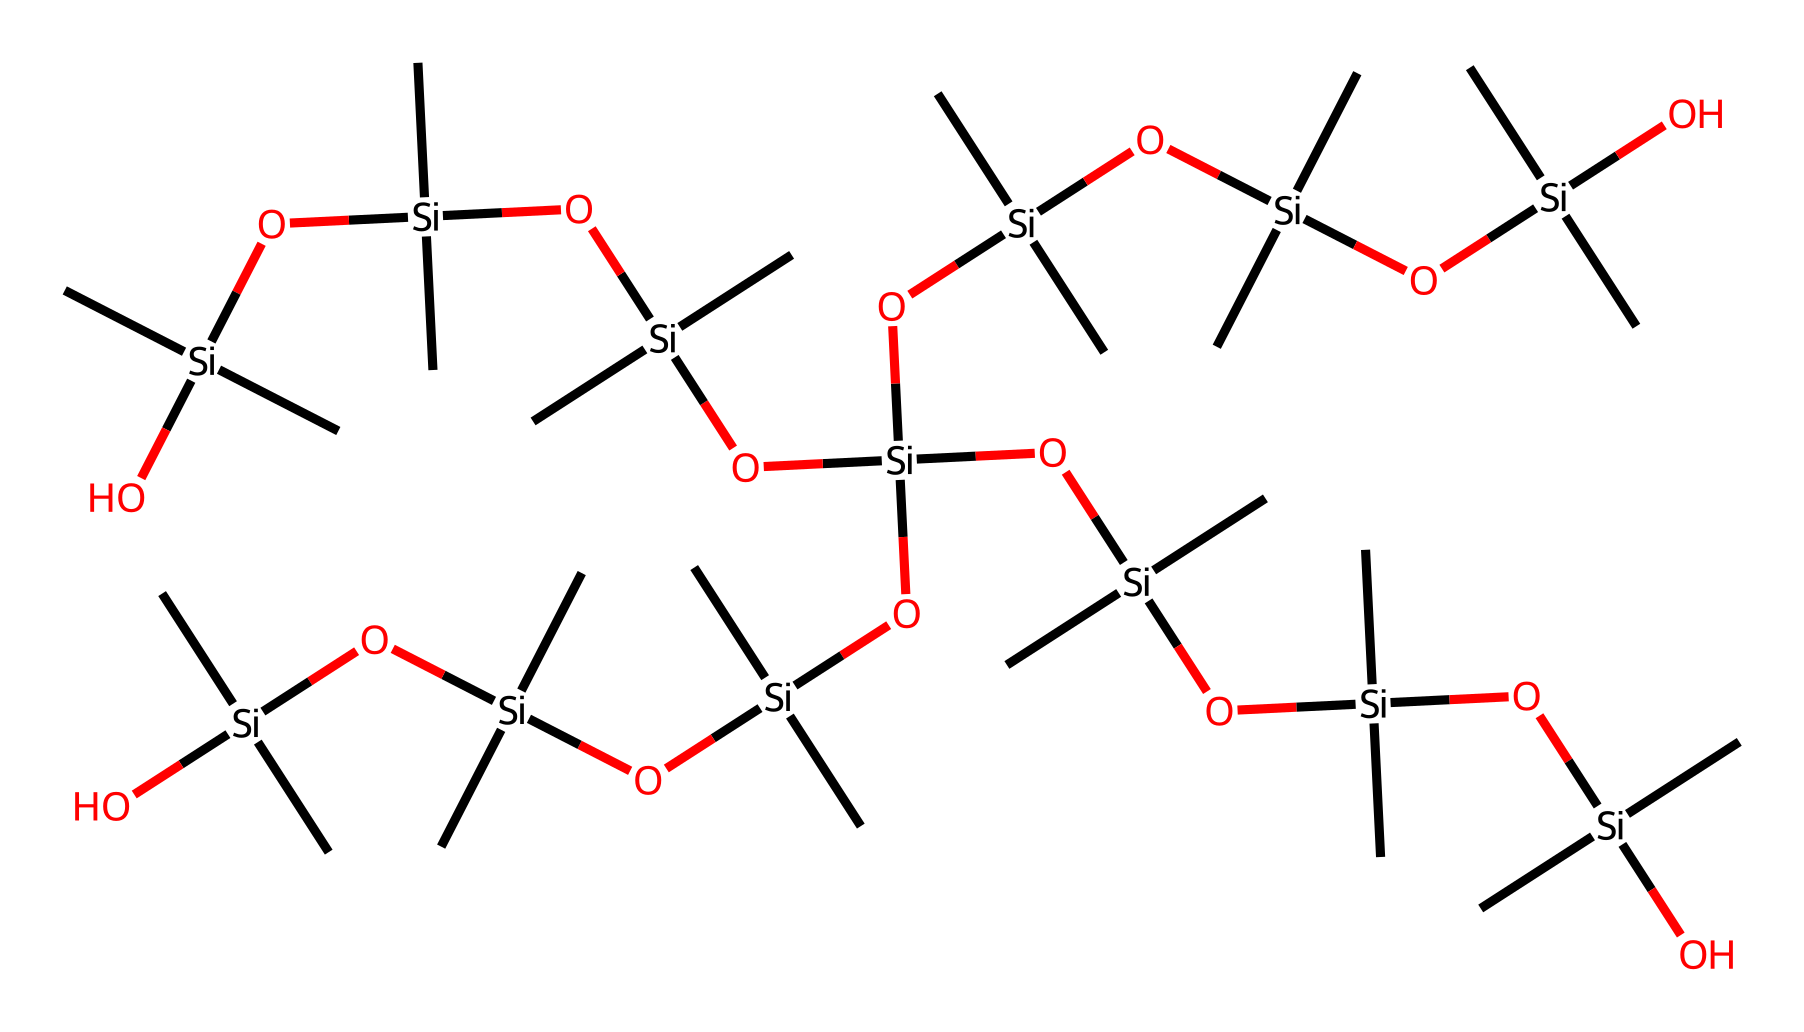What is the central atom in this chemical structure? The central atom in this chemical structure is silicon, as indicated by the presence of the silicon atom [Si] surrounded by oxygen and carbon groups.
Answer: silicon How many silicon atoms are present in this compound? By counting the occurrences of the silicon [Si] symbols in the SMILES representation, we find that there are seven silicon atoms.
Answer: seven What type of functional groups are present in this chemical structure? The presence of hydroxyl groups (-OH) can be inferred from the bonded oxygen atoms connecting the silicon atoms. Each silicon has hydroxy groups attached, indicating that it contains silanol functional groups.
Answer: silanol How many oxygen atoms are included in the structure? Each silicon atom in the structure is bonded to hydroxyl groups, and by visually counting the oxygen atoms attached to silicon, we find a total of six oxygen atoms.
Answer: six What is the primary chemical bond type in this organosilicon compound? The primary bond type in this chemical is the silicon-oxygen bond, which is characteristic of organosilicon compounds, forming the backbone of the structure.
Answer: silicon-oxygen bond What role does the carbon (C) play in this compound? The carbon atoms are part of the methyl groups (C) that are attached to each silicon atom, which contribute hydrophobic properties and influence the glaze's texture and finish in pottery.
Answer: hydrophobic properties 